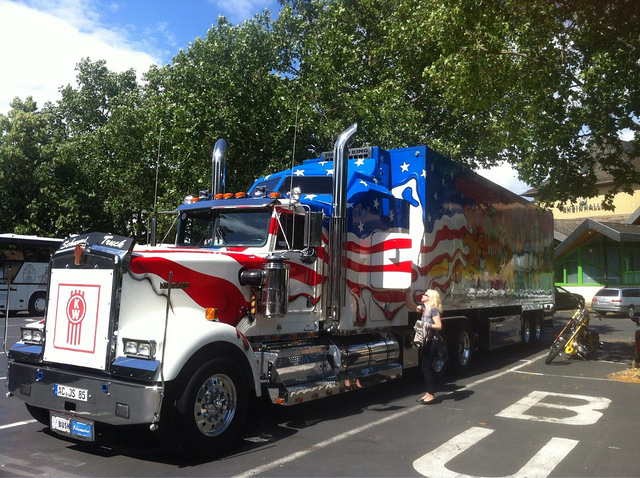Extract all visible text content from this image. KW BU 